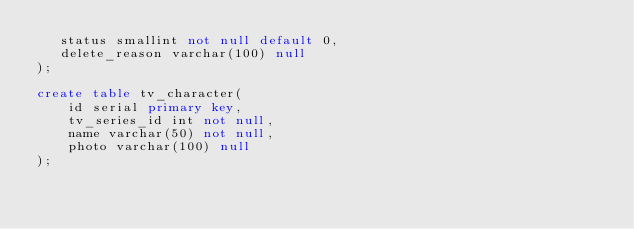Convert code to text. <code><loc_0><loc_0><loc_500><loc_500><_SQL_>   status smallint not null default 0,
   delete_reason varchar(100) null
);

create table tv_character(
    id serial primary key,
    tv_series_id int not null,
    name varchar(50) not null,
    photo varchar(100) null
);
</code> 